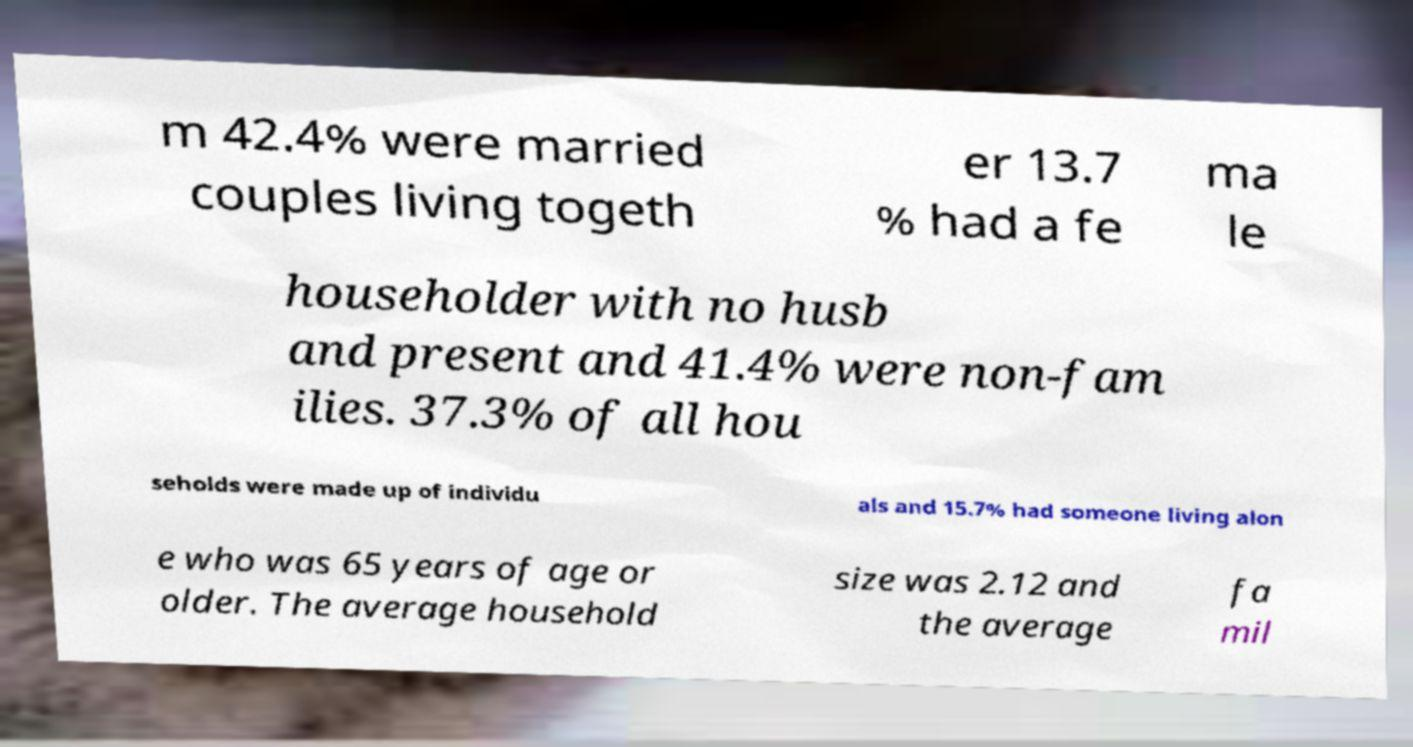I need the written content from this picture converted into text. Can you do that? m 42.4% were married couples living togeth er 13.7 % had a fe ma le householder with no husb and present and 41.4% were non-fam ilies. 37.3% of all hou seholds were made up of individu als and 15.7% had someone living alon e who was 65 years of age or older. The average household size was 2.12 and the average fa mil 